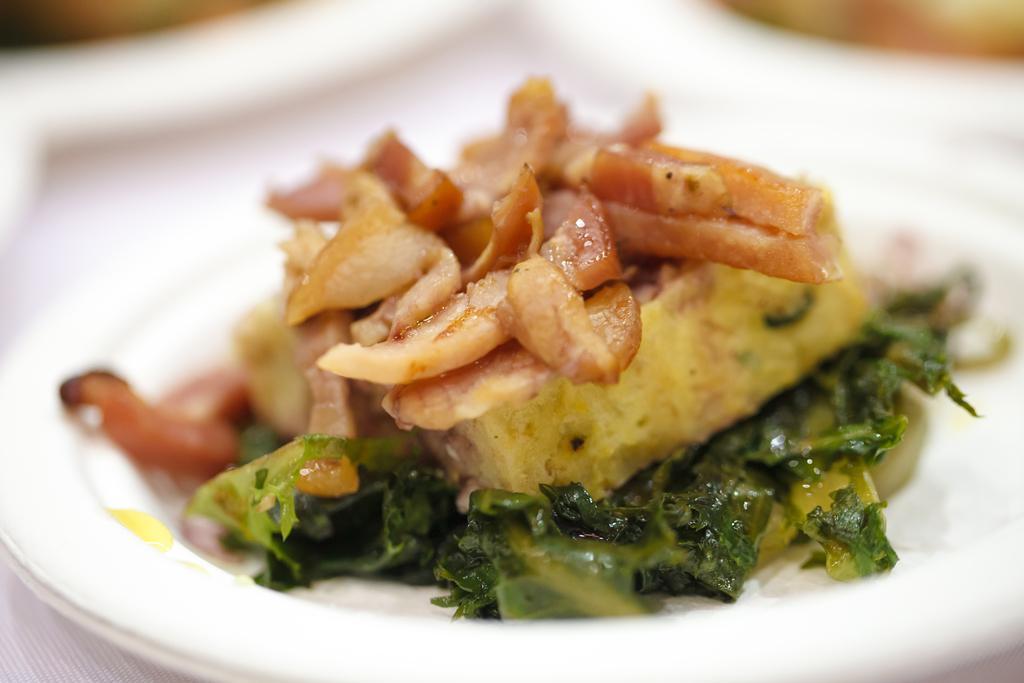How would you summarize this image in a sentence or two? In this image I can see the white colored plate and in the plate I can see a food item which is green, cream, brown and yellow in color. I can see the blurry background. 